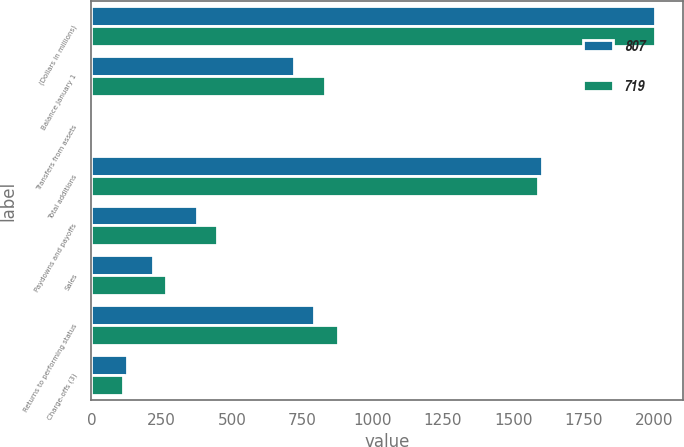Convert chart to OTSL. <chart><loc_0><loc_0><loc_500><loc_500><stacked_bar_chart><ecel><fcel>(Dollars in millions)<fcel>Balance January 1<fcel>Transfers from assets<fcel>Total additions<fcel>Paydowns and payoffs<fcel>Sales<fcel>Returns to performing status<fcel>Charge-offs (3)<nl><fcel>807<fcel>2004<fcel>719<fcel>1<fcel>1604<fcel>376<fcel>219<fcel>793<fcel>128<nl><fcel>719<fcel>2003<fcel>832<fcel>5<fcel>1588<fcel>447<fcel>265<fcel>878<fcel>111<nl></chart> 